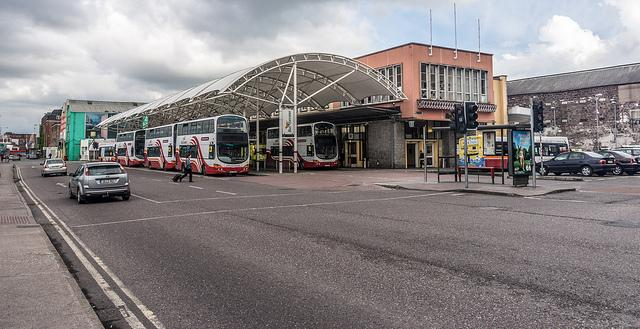What mass transit units sit parked here?

Choices:
A) busses
B) trains
C) cabs
D) cars busses 